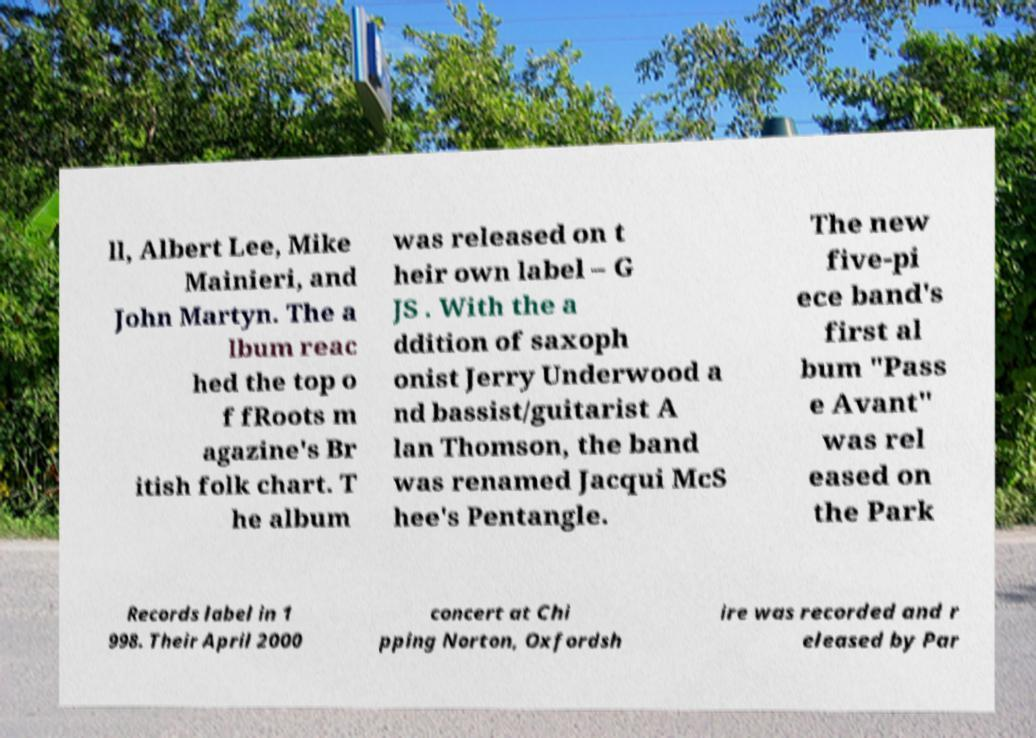There's text embedded in this image that I need extracted. Can you transcribe it verbatim? ll, Albert Lee, Mike Mainieri, and John Martyn. The a lbum reac hed the top o f fRoots m agazine's Br itish folk chart. T he album was released on t heir own label – G JS . With the a ddition of saxoph onist Jerry Underwood a nd bassist/guitarist A lan Thomson, the band was renamed Jacqui McS hee's Pentangle. The new five-pi ece band's first al bum "Pass e Avant" was rel eased on the Park Records label in 1 998. Their April 2000 concert at Chi pping Norton, Oxfordsh ire was recorded and r eleased by Par 